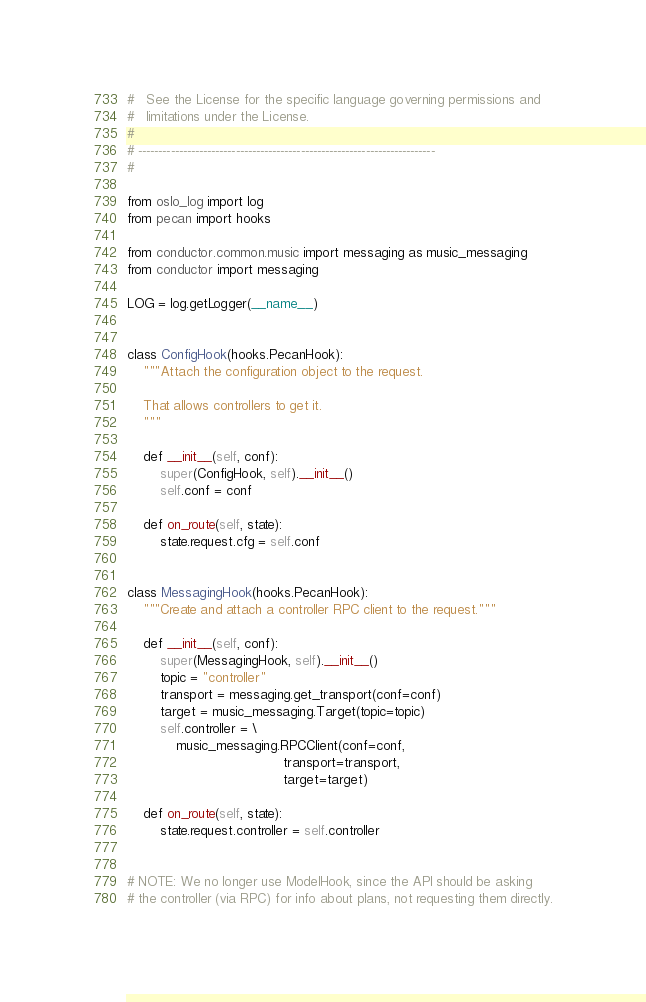<code> <loc_0><loc_0><loc_500><loc_500><_Python_>#   See the License for the specific language governing permissions and
#   limitations under the License.
#
# -------------------------------------------------------------------------
#

from oslo_log import log
from pecan import hooks

from conductor.common.music import messaging as music_messaging
from conductor import messaging

LOG = log.getLogger(__name__)


class ConfigHook(hooks.PecanHook):
    """Attach the configuration object to the request.

    That allows controllers to get it.
    """

    def __init__(self, conf):
        super(ConfigHook, self).__init__()
        self.conf = conf

    def on_route(self, state):
        state.request.cfg = self.conf


class MessagingHook(hooks.PecanHook):
    """Create and attach a controller RPC client to the request."""

    def __init__(self, conf):
        super(MessagingHook, self).__init__()
        topic = "controller"
        transport = messaging.get_transport(conf=conf)
        target = music_messaging.Target(topic=topic)
        self.controller = \
            music_messaging.RPCClient(conf=conf,
                                      transport=transport,
                                      target=target)

    def on_route(self, state):
        state.request.controller = self.controller


# NOTE: We no longer use ModelHook, since the API should be asking
# the controller (via RPC) for info about plans, not requesting them directly.</code> 